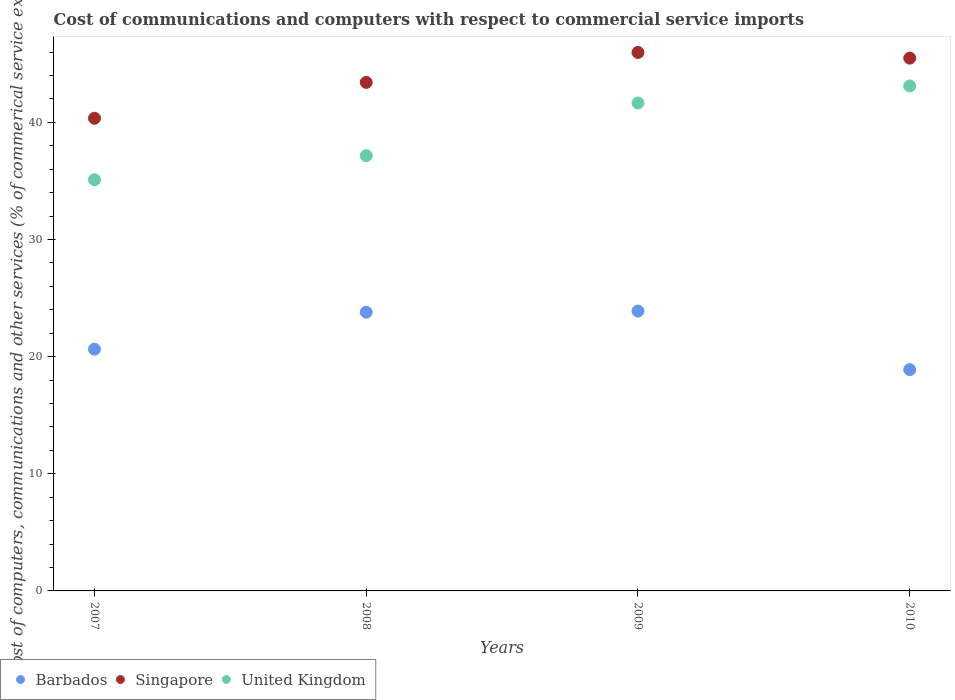How many different coloured dotlines are there?
Your response must be concise. 3. What is the cost of communications and computers in United Kingdom in 2007?
Your response must be concise. 35.1. Across all years, what is the maximum cost of communications and computers in United Kingdom?
Give a very brief answer. 43.11. Across all years, what is the minimum cost of communications and computers in Barbados?
Your answer should be very brief. 18.89. In which year was the cost of communications and computers in Barbados maximum?
Your response must be concise. 2009. What is the total cost of communications and computers in United Kingdom in the graph?
Provide a succinct answer. 157.02. What is the difference between the cost of communications and computers in Singapore in 2007 and that in 2008?
Give a very brief answer. -3.06. What is the difference between the cost of communications and computers in United Kingdom in 2008 and the cost of communications and computers in Singapore in 2007?
Your response must be concise. -3.19. What is the average cost of communications and computers in United Kingdom per year?
Your answer should be very brief. 39.25. In the year 2008, what is the difference between the cost of communications and computers in Singapore and cost of communications and computers in Barbados?
Your response must be concise. 19.62. What is the ratio of the cost of communications and computers in United Kingdom in 2008 to that in 2010?
Give a very brief answer. 0.86. Is the cost of communications and computers in Singapore in 2007 less than that in 2010?
Your answer should be very brief. Yes. What is the difference between the highest and the second highest cost of communications and computers in United Kingdom?
Your response must be concise. 1.45. What is the difference between the highest and the lowest cost of communications and computers in Singapore?
Your answer should be compact. 5.62. In how many years, is the cost of communications and computers in Singapore greater than the average cost of communications and computers in Singapore taken over all years?
Offer a terse response. 2. Is the sum of the cost of communications and computers in Singapore in 2007 and 2010 greater than the maximum cost of communications and computers in Barbados across all years?
Ensure brevity in your answer.  Yes. Is it the case that in every year, the sum of the cost of communications and computers in Singapore and cost of communications and computers in Barbados  is greater than the cost of communications and computers in United Kingdom?
Offer a very short reply. Yes. Does the cost of communications and computers in Singapore monotonically increase over the years?
Provide a short and direct response. No. Is the cost of communications and computers in United Kingdom strictly less than the cost of communications and computers in Barbados over the years?
Make the answer very short. No. How many dotlines are there?
Ensure brevity in your answer.  3. What is the difference between two consecutive major ticks on the Y-axis?
Offer a terse response. 10. Are the values on the major ticks of Y-axis written in scientific E-notation?
Your response must be concise. No. Does the graph contain any zero values?
Offer a very short reply. No. Where does the legend appear in the graph?
Keep it short and to the point. Bottom left. How many legend labels are there?
Give a very brief answer. 3. How are the legend labels stacked?
Provide a succinct answer. Horizontal. What is the title of the graph?
Provide a succinct answer. Cost of communications and computers with respect to commercial service imports. What is the label or title of the Y-axis?
Your answer should be compact. Cost of computers, communications and other services (% of commerical service exports). What is the Cost of computers, communications and other services (% of commerical service exports) of Barbados in 2007?
Offer a very short reply. 20.63. What is the Cost of computers, communications and other services (% of commerical service exports) of Singapore in 2007?
Your answer should be compact. 40.35. What is the Cost of computers, communications and other services (% of commerical service exports) in United Kingdom in 2007?
Provide a short and direct response. 35.1. What is the Cost of computers, communications and other services (% of commerical service exports) in Barbados in 2008?
Provide a succinct answer. 23.79. What is the Cost of computers, communications and other services (% of commerical service exports) of Singapore in 2008?
Your answer should be very brief. 43.41. What is the Cost of computers, communications and other services (% of commerical service exports) in United Kingdom in 2008?
Your answer should be very brief. 37.16. What is the Cost of computers, communications and other services (% of commerical service exports) of Barbados in 2009?
Provide a succinct answer. 23.89. What is the Cost of computers, communications and other services (% of commerical service exports) in Singapore in 2009?
Your answer should be compact. 45.97. What is the Cost of computers, communications and other services (% of commerical service exports) in United Kingdom in 2009?
Keep it short and to the point. 41.65. What is the Cost of computers, communications and other services (% of commerical service exports) of Barbados in 2010?
Keep it short and to the point. 18.89. What is the Cost of computers, communications and other services (% of commerical service exports) of Singapore in 2010?
Make the answer very short. 45.48. What is the Cost of computers, communications and other services (% of commerical service exports) in United Kingdom in 2010?
Give a very brief answer. 43.11. Across all years, what is the maximum Cost of computers, communications and other services (% of commerical service exports) of Barbados?
Ensure brevity in your answer.  23.89. Across all years, what is the maximum Cost of computers, communications and other services (% of commerical service exports) of Singapore?
Offer a very short reply. 45.97. Across all years, what is the maximum Cost of computers, communications and other services (% of commerical service exports) in United Kingdom?
Make the answer very short. 43.11. Across all years, what is the minimum Cost of computers, communications and other services (% of commerical service exports) in Barbados?
Keep it short and to the point. 18.89. Across all years, what is the minimum Cost of computers, communications and other services (% of commerical service exports) in Singapore?
Offer a terse response. 40.35. Across all years, what is the minimum Cost of computers, communications and other services (% of commerical service exports) of United Kingdom?
Offer a very short reply. 35.1. What is the total Cost of computers, communications and other services (% of commerical service exports) of Barbados in the graph?
Your answer should be very brief. 87.21. What is the total Cost of computers, communications and other services (% of commerical service exports) in Singapore in the graph?
Your response must be concise. 175.21. What is the total Cost of computers, communications and other services (% of commerical service exports) of United Kingdom in the graph?
Give a very brief answer. 157.02. What is the difference between the Cost of computers, communications and other services (% of commerical service exports) of Barbados in 2007 and that in 2008?
Your answer should be compact. -3.16. What is the difference between the Cost of computers, communications and other services (% of commerical service exports) in Singapore in 2007 and that in 2008?
Offer a terse response. -3.06. What is the difference between the Cost of computers, communications and other services (% of commerical service exports) of United Kingdom in 2007 and that in 2008?
Your answer should be very brief. -2.05. What is the difference between the Cost of computers, communications and other services (% of commerical service exports) of Barbados in 2007 and that in 2009?
Your response must be concise. -3.26. What is the difference between the Cost of computers, communications and other services (% of commerical service exports) of Singapore in 2007 and that in 2009?
Make the answer very short. -5.62. What is the difference between the Cost of computers, communications and other services (% of commerical service exports) of United Kingdom in 2007 and that in 2009?
Provide a short and direct response. -6.55. What is the difference between the Cost of computers, communications and other services (% of commerical service exports) in Barbados in 2007 and that in 2010?
Your answer should be very brief. 1.75. What is the difference between the Cost of computers, communications and other services (% of commerical service exports) in Singapore in 2007 and that in 2010?
Offer a terse response. -5.13. What is the difference between the Cost of computers, communications and other services (% of commerical service exports) in United Kingdom in 2007 and that in 2010?
Your answer should be very brief. -8. What is the difference between the Cost of computers, communications and other services (% of commerical service exports) of Barbados in 2008 and that in 2009?
Your response must be concise. -0.1. What is the difference between the Cost of computers, communications and other services (% of commerical service exports) in Singapore in 2008 and that in 2009?
Provide a succinct answer. -2.56. What is the difference between the Cost of computers, communications and other services (% of commerical service exports) of United Kingdom in 2008 and that in 2009?
Your response must be concise. -4.5. What is the difference between the Cost of computers, communications and other services (% of commerical service exports) of Barbados in 2008 and that in 2010?
Your answer should be very brief. 4.91. What is the difference between the Cost of computers, communications and other services (% of commerical service exports) of Singapore in 2008 and that in 2010?
Offer a terse response. -2.07. What is the difference between the Cost of computers, communications and other services (% of commerical service exports) of United Kingdom in 2008 and that in 2010?
Provide a succinct answer. -5.95. What is the difference between the Cost of computers, communications and other services (% of commerical service exports) of Barbados in 2009 and that in 2010?
Offer a very short reply. 5. What is the difference between the Cost of computers, communications and other services (% of commerical service exports) in Singapore in 2009 and that in 2010?
Your answer should be very brief. 0.49. What is the difference between the Cost of computers, communications and other services (% of commerical service exports) of United Kingdom in 2009 and that in 2010?
Provide a succinct answer. -1.45. What is the difference between the Cost of computers, communications and other services (% of commerical service exports) in Barbados in 2007 and the Cost of computers, communications and other services (% of commerical service exports) in Singapore in 2008?
Your answer should be very brief. -22.78. What is the difference between the Cost of computers, communications and other services (% of commerical service exports) of Barbados in 2007 and the Cost of computers, communications and other services (% of commerical service exports) of United Kingdom in 2008?
Your answer should be very brief. -16.52. What is the difference between the Cost of computers, communications and other services (% of commerical service exports) of Singapore in 2007 and the Cost of computers, communications and other services (% of commerical service exports) of United Kingdom in 2008?
Provide a short and direct response. 3.19. What is the difference between the Cost of computers, communications and other services (% of commerical service exports) in Barbados in 2007 and the Cost of computers, communications and other services (% of commerical service exports) in Singapore in 2009?
Give a very brief answer. -25.33. What is the difference between the Cost of computers, communications and other services (% of commerical service exports) in Barbados in 2007 and the Cost of computers, communications and other services (% of commerical service exports) in United Kingdom in 2009?
Your answer should be compact. -21.02. What is the difference between the Cost of computers, communications and other services (% of commerical service exports) of Singapore in 2007 and the Cost of computers, communications and other services (% of commerical service exports) of United Kingdom in 2009?
Keep it short and to the point. -1.3. What is the difference between the Cost of computers, communications and other services (% of commerical service exports) of Barbados in 2007 and the Cost of computers, communications and other services (% of commerical service exports) of Singapore in 2010?
Your response must be concise. -24.85. What is the difference between the Cost of computers, communications and other services (% of commerical service exports) of Barbados in 2007 and the Cost of computers, communications and other services (% of commerical service exports) of United Kingdom in 2010?
Give a very brief answer. -22.47. What is the difference between the Cost of computers, communications and other services (% of commerical service exports) in Singapore in 2007 and the Cost of computers, communications and other services (% of commerical service exports) in United Kingdom in 2010?
Give a very brief answer. -2.76. What is the difference between the Cost of computers, communications and other services (% of commerical service exports) in Barbados in 2008 and the Cost of computers, communications and other services (% of commerical service exports) in Singapore in 2009?
Offer a very short reply. -22.17. What is the difference between the Cost of computers, communications and other services (% of commerical service exports) in Barbados in 2008 and the Cost of computers, communications and other services (% of commerical service exports) in United Kingdom in 2009?
Your response must be concise. -17.86. What is the difference between the Cost of computers, communications and other services (% of commerical service exports) of Singapore in 2008 and the Cost of computers, communications and other services (% of commerical service exports) of United Kingdom in 2009?
Keep it short and to the point. 1.76. What is the difference between the Cost of computers, communications and other services (% of commerical service exports) of Barbados in 2008 and the Cost of computers, communications and other services (% of commerical service exports) of Singapore in 2010?
Offer a terse response. -21.69. What is the difference between the Cost of computers, communications and other services (% of commerical service exports) in Barbados in 2008 and the Cost of computers, communications and other services (% of commerical service exports) in United Kingdom in 2010?
Ensure brevity in your answer.  -19.31. What is the difference between the Cost of computers, communications and other services (% of commerical service exports) of Singapore in 2008 and the Cost of computers, communications and other services (% of commerical service exports) of United Kingdom in 2010?
Your response must be concise. 0.31. What is the difference between the Cost of computers, communications and other services (% of commerical service exports) in Barbados in 2009 and the Cost of computers, communications and other services (% of commerical service exports) in Singapore in 2010?
Make the answer very short. -21.59. What is the difference between the Cost of computers, communications and other services (% of commerical service exports) in Barbados in 2009 and the Cost of computers, communications and other services (% of commerical service exports) in United Kingdom in 2010?
Offer a terse response. -19.22. What is the difference between the Cost of computers, communications and other services (% of commerical service exports) of Singapore in 2009 and the Cost of computers, communications and other services (% of commerical service exports) of United Kingdom in 2010?
Your response must be concise. 2.86. What is the average Cost of computers, communications and other services (% of commerical service exports) of Barbados per year?
Give a very brief answer. 21.8. What is the average Cost of computers, communications and other services (% of commerical service exports) of Singapore per year?
Make the answer very short. 43.8. What is the average Cost of computers, communications and other services (% of commerical service exports) of United Kingdom per year?
Ensure brevity in your answer.  39.25. In the year 2007, what is the difference between the Cost of computers, communications and other services (% of commerical service exports) in Barbados and Cost of computers, communications and other services (% of commerical service exports) in Singapore?
Your response must be concise. -19.72. In the year 2007, what is the difference between the Cost of computers, communications and other services (% of commerical service exports) in Barbados and Cost of computers, communications and other services (% of commerical service exports) in United Kingdom?
Provide a succinct answer. -14.47. In the year 2007, what is the difference between the Cost of computers, communications and other services (% of commerical service exports) in Singapore and Cost of computers, communications and other services (% of commerical service exports) in United Kingdom?
Keep it short and to the point. 5.25. In the year 2008, what is the difference between the Cost of computers, communications and other services (% of commerical service exports) in Barbados and Cost of computers, communications and other services (% of commerical service exports) in Singapore?
Give a very brief answer. -19.62. In the year 2008, what is the difference between the Cost of computers, communications and other services (% of commerical service exports) in Barbados and Cost of computers, communications and other services (% of commerical service exports) in United Kingdom?
Ensure brevity in your answer.  -13.36. In the year 2008, what is the difference between the Cost of computers, communications and other services (% of commerical service exports) of Singapore and Cost of computers, communications and other services (% of commerical service exports) of United Kingdom?
Give a very brief answer. 6.26. In the year 2009, what is the difference between the Cost of computers, communications and other services (% of commerical service exports) in Barbados and Cost of computers, communications and other services (% of commerical service exports) in Singapore?
Offer a very short reply. -22.08. In the year 2009, what is the difference between the Cost of computers, communications and other services (% of commerical service exports) of Barbados and Cost of computers, communications and other services (% of commerical service exports) of United Kingdom?
Provide a succinct answer. -17.76. In the year 2009, what is the difference between the Cost of computers, communications and other services (% of commerical service exports) in Singapore and Cost of computers, communications and other services (% of commerical service exports) in United Kingdom?
Your response must be concise. 4.31. In the year 2010, what is the difference between the Cost of computers, communications and other services (% of commerical service exports) of Barbados and Cost of computers, communications and other services (% of commerical service exports) of Singapore?
Provide a succinct answer. -26.59. In the year 2010, what is the difference between the Cost of computers, communications and other services (% of commerical service exports) of Barbados and Cost of computers, communications and other services (% of commerical service exports) of United Kingdom?
Offer a terse response. -24.22. In the year 2010, what is the difference between the Cost of computers, communications and other services (% of commerical service exports) in Singapore and Cost of computers, communications and other services (% of commerical service exports) in United Kingdom?
Give a very brief answer. 2.37. What is the ratio of the Cost of computers, communications and other services (% of commerical service exports) of Barbados in 2007 to that in 2008?
Your response must be concise. 0.87. What is the ratio of the Cost of computers, communications and other services (% of commerical service exports) in Singapore in 2007 to that in 2008?
Make the answer very short. 0.93. What is the ratio of the Cost of computers, communications and other services (% of commerical service exports) in United Kingdom in 2007 to that in 2008?
Provide a short and direct response. 0.94. What is the ratio of the Cost of computers, communications and other services (% of commerical service exports) in Barbados in 2007 to that in 2009?
Ensure brevity in your answer.  0.86. What is the ratio of the Cost of computers, communications and other services (% of commerical service exports) in Singapore in 2007 to that in 2009?
Keep it short and to the point. 0.88. What is the ratio of the Cost of computers, communications and other services (% of commerical service exports) of United Kingdom in 2007 to that in 2009?
Offer a very short reply. 0.84. What is the ratio of the Cost of computers, communications and other services (% of commerical service exports) in Barbados in 2007 to that in 2010?
Offer a very short reply. 1.09. What is the ratio of the Cost of computers, communications and other services (% of commerical service exports) of Singapore in 2007 to that in 2010?
Provide a short and direct response. 0.89. What is the ratio of the Cost of computers, communications and other services (% of commerical service exports) in United Kingdom in 2007 to that in 2010?
Offer a very short reply. 0.81. What is the ratio of the Cost of computers, communications and other services (% of commerical service exports) of Singapore in 2008 to that in 2009?
Provide a short and direct response. 0.94. What is the ratio of the Cost of computers, communications and other services (% of commerical service exports) of United Kingdom in 2008 to that in 2009?
Your answer should be compact. 0.89. What is the ratio of the Cost of computers, communications and other services (% of commerical service exports) of Barbados in 2008 to that in 2010?
Keep it short and to the point. 1.26. What is the ratio of the Cost of computers, communications and other services (% of commerical service exports) in Singapore in 2008 to that in 2010?
Give a very brief answer. 0.95. What is the ratio of the Cost of computers, communications and other services (% of commerical service exports) of United Kingdom in 2008 to that in 2010?
Offer a terse response. 0.86. What is the ratio of the Cost of computers, communications and other services (% of commerical service exports) in Barbados in 2009 to that in 2010?
Your answer should be very brief. 1.26. What is the ratio of the Cost of computers, communications and other services (% of commerical service exports) in Singapore in 2009 to that in 2010?
Provide a succinct answer. 1.01. What is the ratio of the Cost of computers, communications and other services (% of commerical service exports) in United Kingdom in 2009 to that in 2010?
Provide a short and direct response. 0.97. What is the difference between the highest and the second highest Cost of computers, communications and other services (% of commerical service exports) in Barbados?
Give a very brief answer. 0.1. What is the difference between the highest and the second highest Cost of computers, communications and other services (% of commerical service exports) of Singapore?
Provide a succinct answer. 0.49. What is the difference between the highest and the second highest Cost of computers, communications and other services (% of commerical service exports) of United Kingdom?
Your answer should be compact. 1.45. What is the difference between the highest and the lowest Cost of computers, communications and other services (% of commerical service exports) of Barbados?
Give a very brief answer. 5. What is the difference between the highest and the lowest Cost of computers, communications and other services (% of commerical service exports) of Singapore?
Your answer should be very brief. 5.62. What is the difference between the highest and the lowest Cost of computers, communications and other services (% of commerical service exports) of United Kingdom?
Give a very brief answer. 8. 